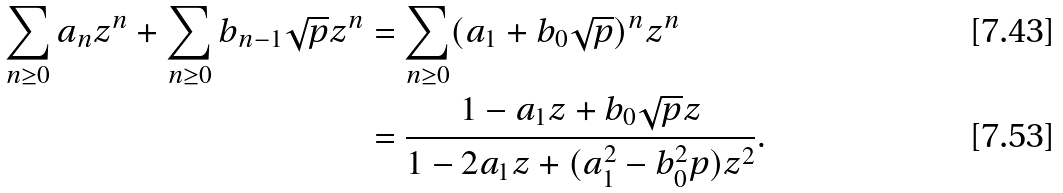Convert formula to latex. <formula><loc_0><loc_0><loc_500><loc_500>\sum _ { n \geq 0 } a _ { n } z ^ { n } + \sum _ { n \geq 0 } b _ { n - 1 } \sqrt { p } z ^ { n } & = \sum _ { n \geq 0 } ( a _ { 1 } + b _ { 0 } \sqrt { p } ) ^ { n } z ^ { n } \\ & = \frac { 1 - a _ { 1 } z + b _ { 0 } \sqrt { p } z } { 1 - 2 a _ { 1 } z + ( a _ { 1 } ^ { 2 } - b _ { 0 } ^ { 2 } p ) z ^ { 2 } } .</formula> 